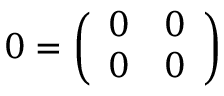Convert formula to latex. <formula><loc_0><loc_0><loc_500><loc_500>0 = { \left ( \begin{array} { l l } { 0 } & { 0 } \\ { 0 } & { 0 } \end{array} \right ) }</formula> 